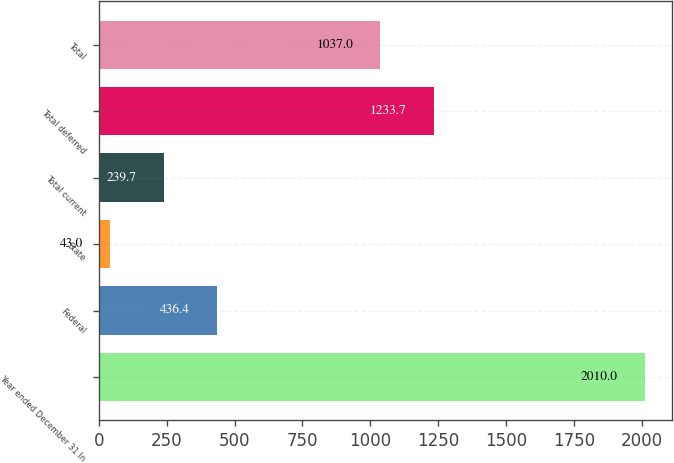Convert chart to OTSL. <chart><loc_0><loc_0><loc_500><loc_500><bar_chart><fcel>Year ended December 31 In<fcel>Federal<fcel>State<fcel>Total current<fcel>Total deferred<fcel>Total<nl><fcel>2010<fcel>436.4<fcel>43<fcel>239.7<fcel>1233.7<fcel>1037<nl></chart> 